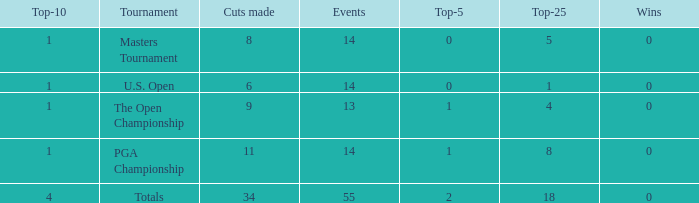What is the average top-5 when the cuts made is more than 34? None. 